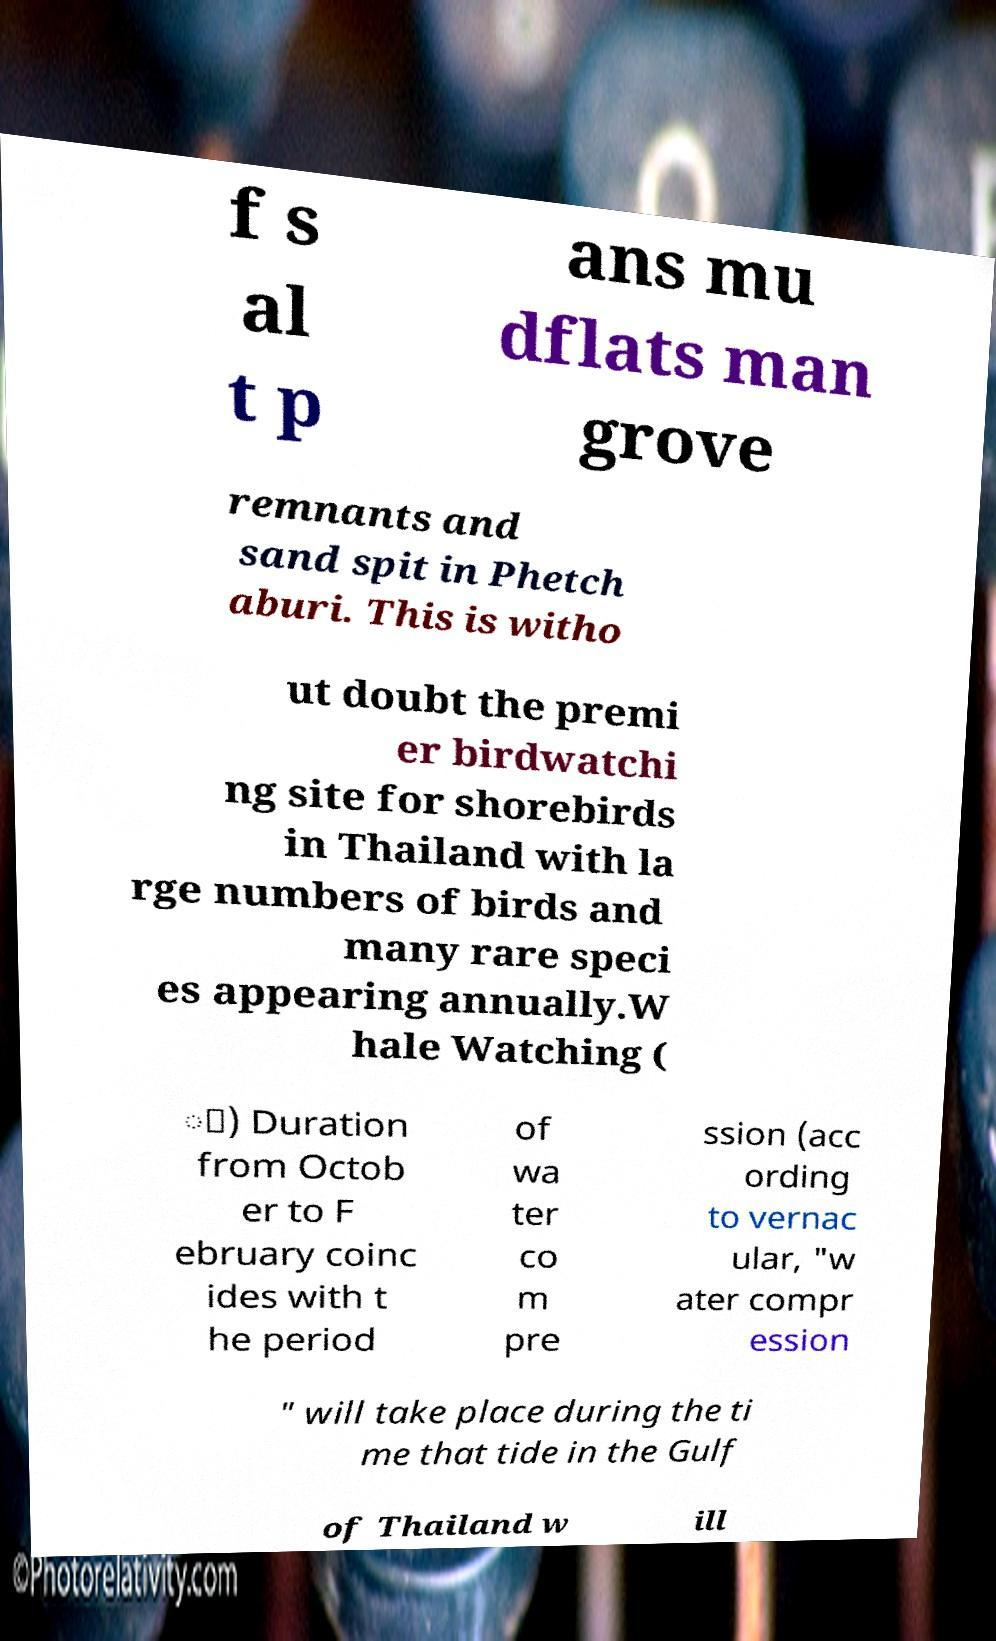I need the written content from this picture converted into text. Can you do that? f s al t p ans mu dflats man grove remnants and sand spit in Phetch aburi. This is witho ut doubt the premi er birdwatchi ng site for shorebirds in Thailand with la rge numbers of birds and many rare speci es appearing annually.W hale Watching ( ู) Duration from Octob er to F ebruary coinc ides with t he period of wa ter co m pre ssion (acc ording to vernac ular, "w ater compr ession " will take place during the ti me that tide in the Gulf of Thailand w ill 